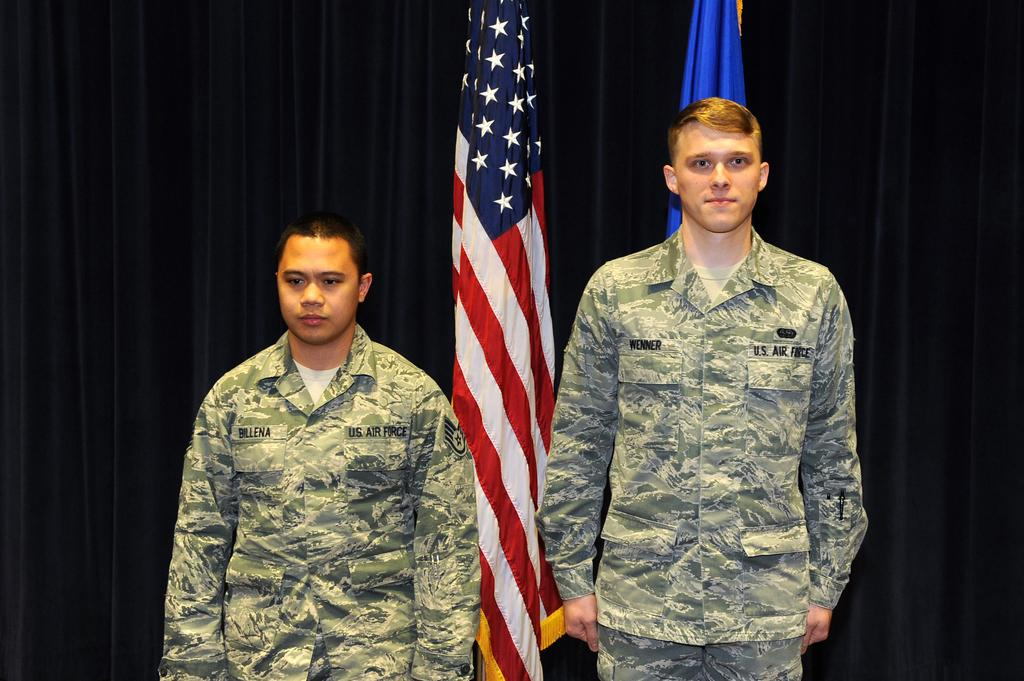How many people are in the image? There are two persons in the image. What can be seen in the background of the image? There are two flags and a black curtain in the background of the image. What type of lead is being used by the persons in the image? There is no lead present in the image, and the persons are not using any lead. 